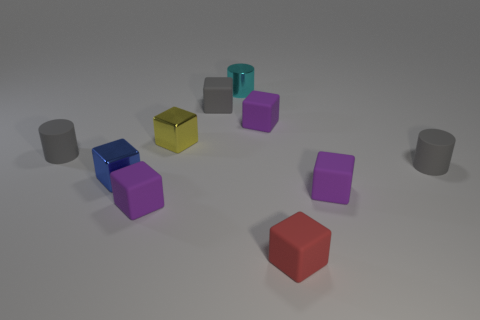What number of yellow shiny cubes are behind the small yellow shiny thing?
Ensure brevity in your answer.  0. What is the tiny blue cube made of?
Give a very brief answer. Metal. Is the number of small purple matte cubes that are right of the tiny cyan object less than the number of objects?
Offer a very short reply. Yes. What is the color of the thing to the left of the blue metallic block?
Your answer should be very brief. Gray. The small yellow thing has what shape?
Your answer should be compact. Cube. Are there any tiny red things behind the gray cylinder to the left of the tiny gray cylinder that is right of the small gray matte block?
Provide a succinct answer. No. The cylinder that is right of the rubber cube in front of the purple thing on the left side of the gray cube is what color?
Provide a short and direct response. Gray. What material is the tiny gray object that is the same shape as the red thing?
Your answer should be compact. Rubber. There is a cylinder that is on the left side of the tiny purple rubber thing to the left of the yellow block; what size is it?
Make the answer very short. Small. What is the small blue object that is in front of the tiny gray matte block made of?
Your answer should be compact. Metal. 